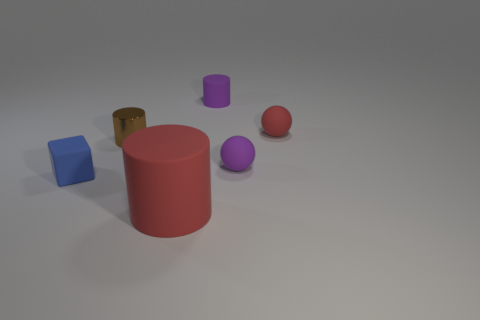Is there any other thing that has the same material as the small brown thing?
Offer a terse response. No. There is a sphere that is in front of the shiny thing; is it the same size as the red matte thing that is behind the tiny blue cube?
Give a very brief answer. Yes. How many things are either tiny red spheres or tiny purple cylinders that are behind the tiny rubber block?
Provide a short and direct response. 2. Is there another big red thing that has the same shape as the metallic object?
Offer a terse response. Yes. There is a red thing in front of the tiny ball in front of the tiny metal cylinder; how big is it?
Provide a succinct answer. Large. Does the shiny object have the same color as the large rubber object?
Provide a succinct answer. No. How many metallic objects are either cylinders or blue cubes?
Ensure brevity in your answer.  1. How many small red matte spheres are there?
Make the answer very short. 1. Does the red thing that is in front of the small shiny cylinder have the same material as the brown object that is to the right of the small blue matte thing?
Your answer should be compact. No. The other object that is the same shape as the small red matte thing is what color?
Offer a very short reply. Purple. 